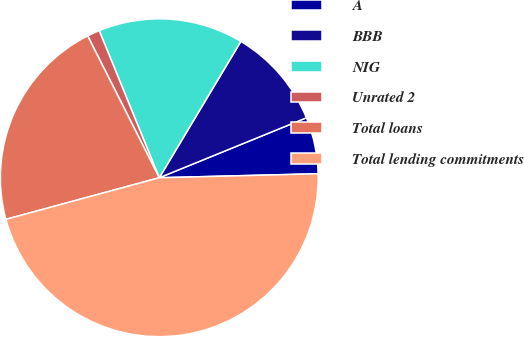Convert chart to OTSL. <chart><loc_0><loc_0><loc_500><loc_500><pie_chart><fcel>A<fcel>BBB<fcel>NIG<fcel>Unrated 2<fcel>Total loans<fcel>Total lending commitments<nl><fcel>5.76%<fcel>10.26%<fcel>14.75%<fcel>1.27%<fcel>21.78%<fcel>46.19%<nl></chart> 